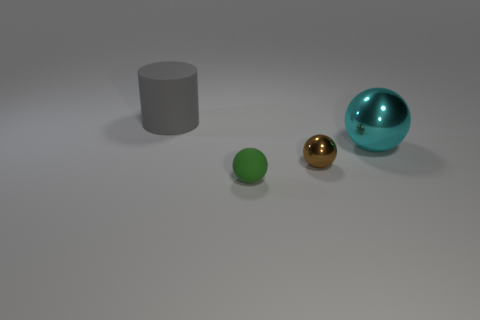Add 4 big objects. How many objects exist? 8 Subtract all balls. How many objects are left? 1 Add 3 gray matte cylinders. How many gray matte cylinders exist? 4 Subtract 0 cyan cylinders. How many objects are left? 4 Subtract all brown matte spheres. Subtract all rubber cylinders. How many objects are left? 3 Add 4 brown metal balls. How many brown metal balls are left? 5 